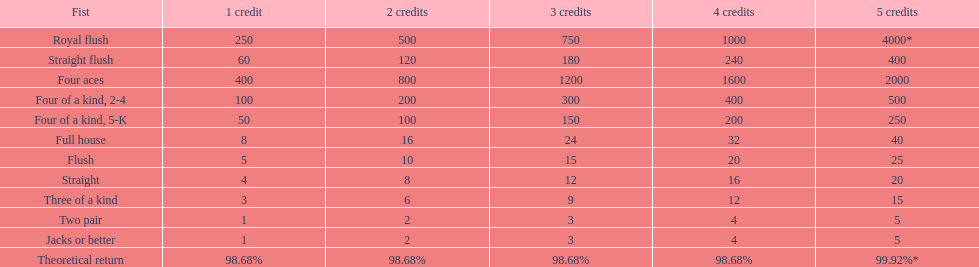Which is a higher standing hand: a straight or a flush? Flush. 